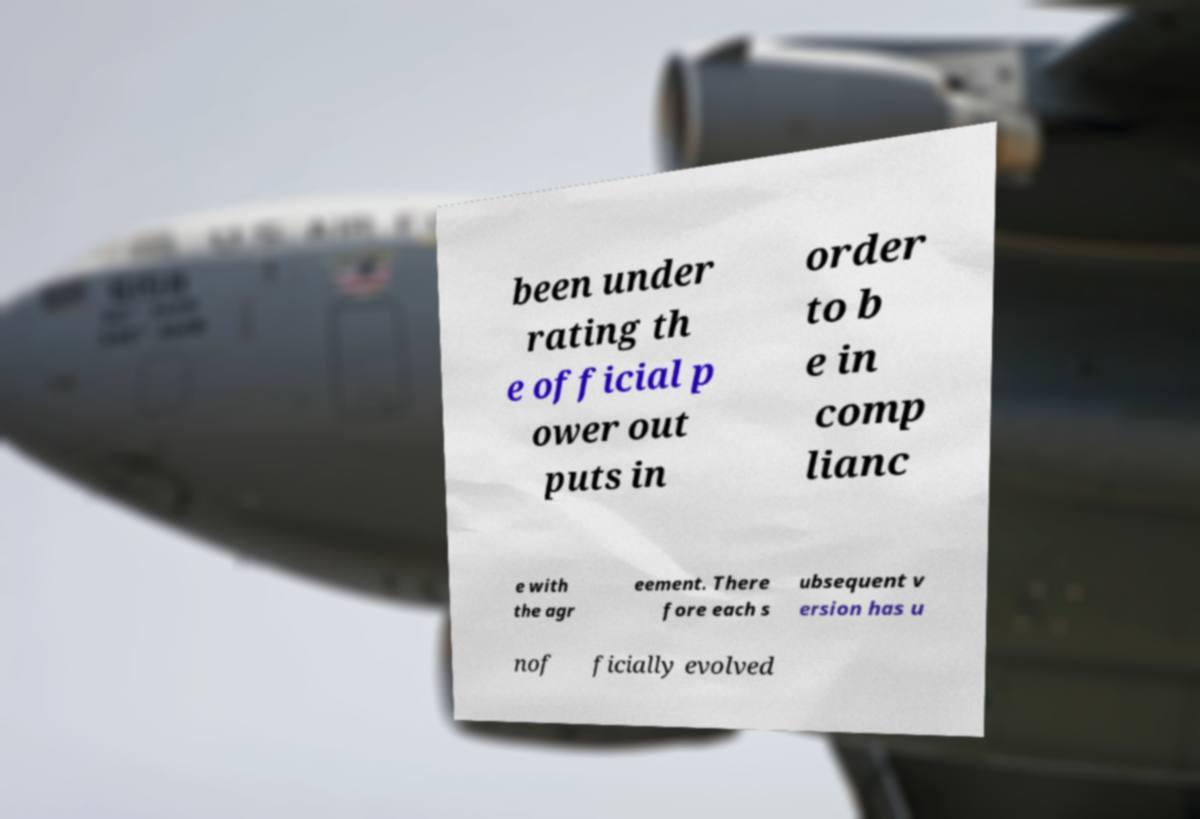I need the written content from this picture converted into text. Can you do that? been under rating th e official p ower out puts in order to b e in comp lianc e with the agr eement. There fore each s ubsequent v ersion has u nof ficially evolved 